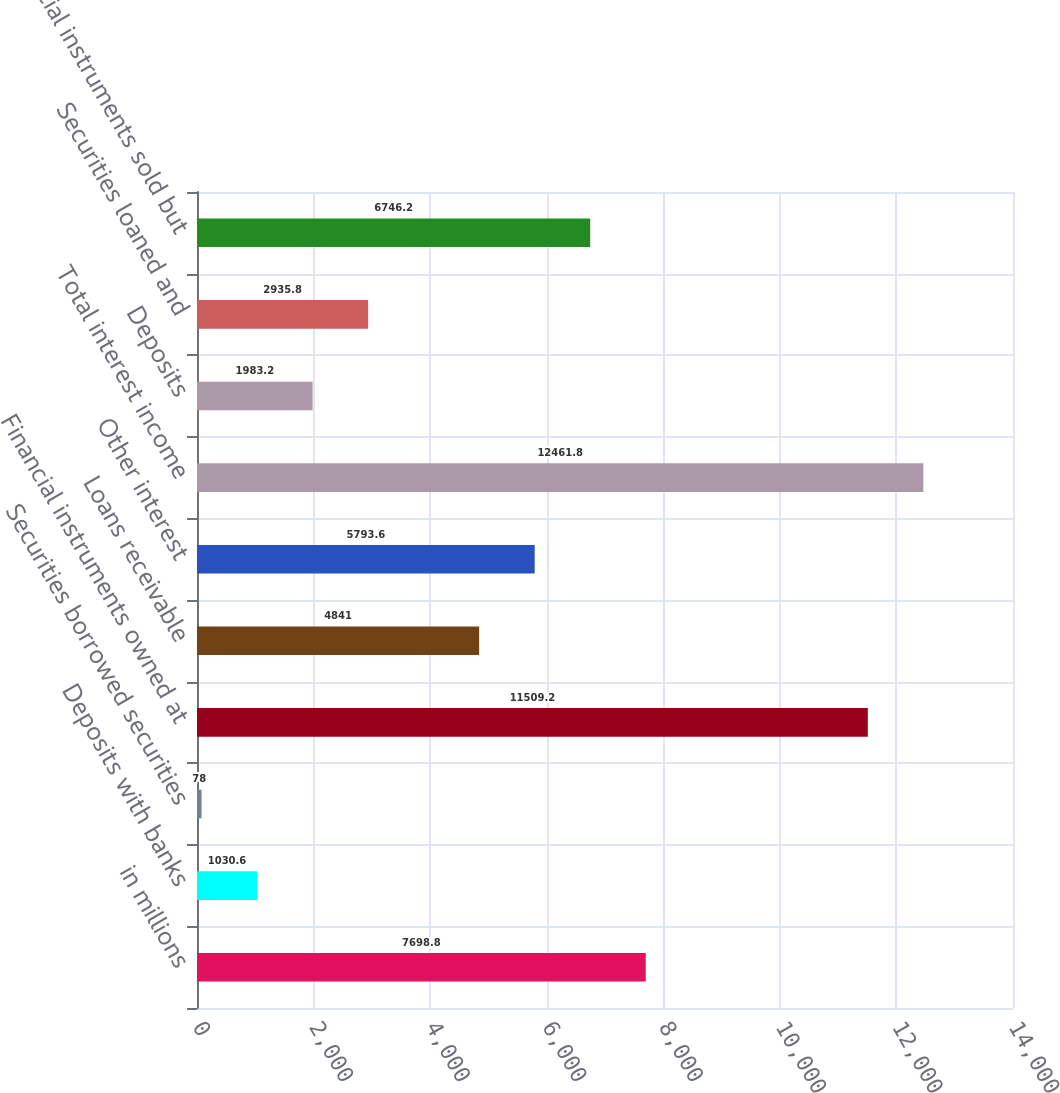<chart> <loc_0><loc_0><loc_500><loc_500><bar_chart><fcel>in millions<fcel>Deposits with banks<fcel>Securities borrowed securities<fcel>Financial instruments owned at<fcel>Loans receivable<fcel>Other interest<fcel>Total interest income<fcel>Deposits<fcel>Securities loaned and<fcel>Financial instruments sold but<nl><fcel>7698.8<fcel>1030.6<fcel>78<fcel>11509.2<fcel>4841<fcel>5793.6<fcel>12461.8<fcel>1983.2<fcel>2935.8<fcel>6746.2<nl></chart> 